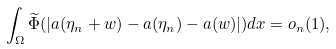Convert formula to latex. <formula><loc_0><loc_0><loc_500><loc_500>\int _ { \Omega } \widetilde { \Phi } ( | a ( \eta _ { n } + w ) - a ( \eta _ { n } ) - a ( w ) | ) d x = o _ { n } ( 1 ) ,</formula> 